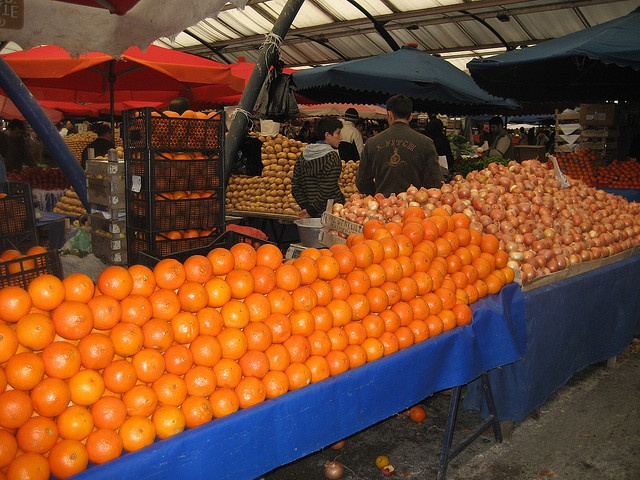Describe the objects in this image and their specific colors. I can see orange in maroon, red, orange, and brown tones, umbrella in maroon, black, purple, darkblue, and gray tones, umbrella in maroon, black, purple, and darkblue tones, umbrella in maroon, brown, black, and red tones, and people in maroon, black, and brown tones in this image. 